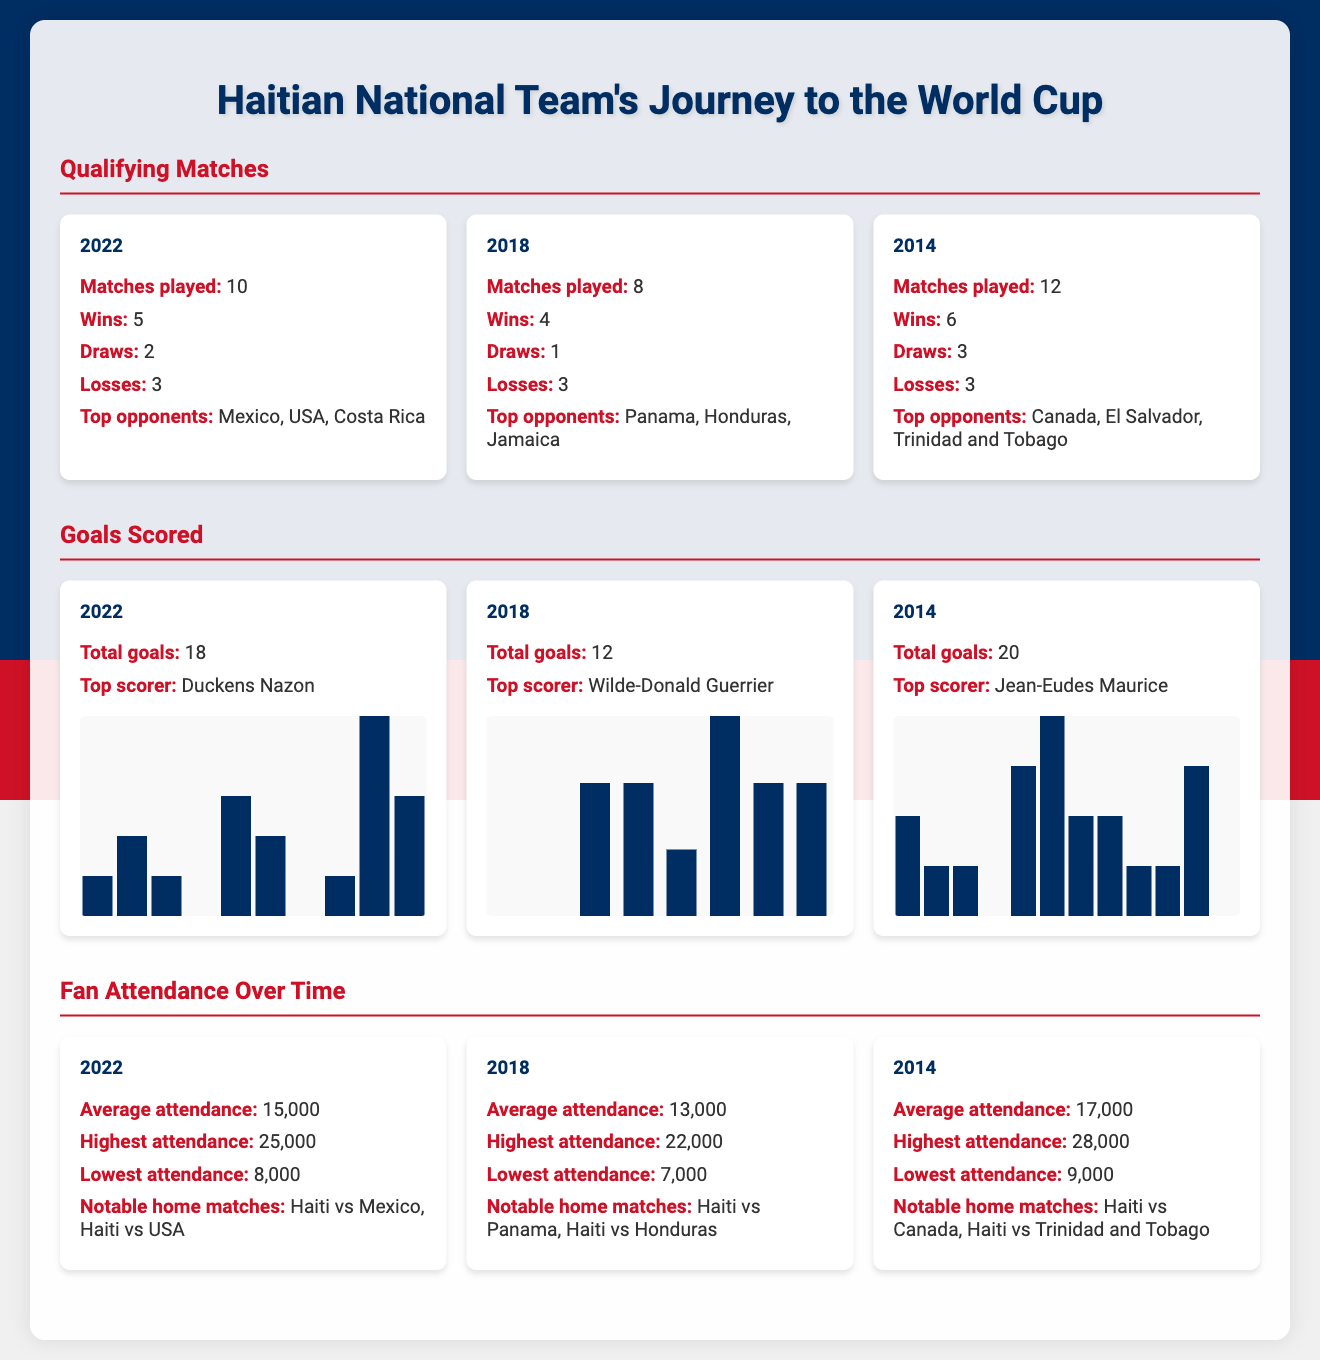What year did the Haitian National Team play 10 qualifying matches? The document states that in 2022, Haiti played 10 qualifying matches.
Answer: 2022 Who was the top scorer for the Haitian National Team in 2014? According to the document, the top scorer in 2014 was Jean-Eudes Maurice.
Answer: Jean-Eudes Maurice What was the highest attendance for the Haitian National Team in 2022? The document lists the highest attendance in 2022 as 25,000.
Answer: 25,000 How many wins did the Haitian National Team have in 2018? The document indicates that in 2018, Haiti had 4 wins.
Answer: 4 What is the average attendance for the Haitian National Team matches in 2018? Per the document, the average attendance in 2018 was 13,000.
Answer: 13,000 Which year had the highest total goals scored by the Haitian National Team? The document shows that in 2014, Haiti scored a total of 20 goals, the highest among the years listed.
Answer: 20 How many draws did the Haitian National Team have in 2022? The document specifies that Haiti had 2 draws in 2022.
Answer: 2 What notable home matches are mentioned for 2022? The document states that notable home matches in 2022 were Haiti vs Mexico and Haiti vs USA.
Answer: Haiti vs Mexico, Haiti vs USA What percentage of total goals did the top scorer for 2022 score? The document indicates that Duckens Nazon was the top scorer in 2022, scoring a significant portion of the total 18 goals, but does not specify the exact percentage.
Answer: Not specified 